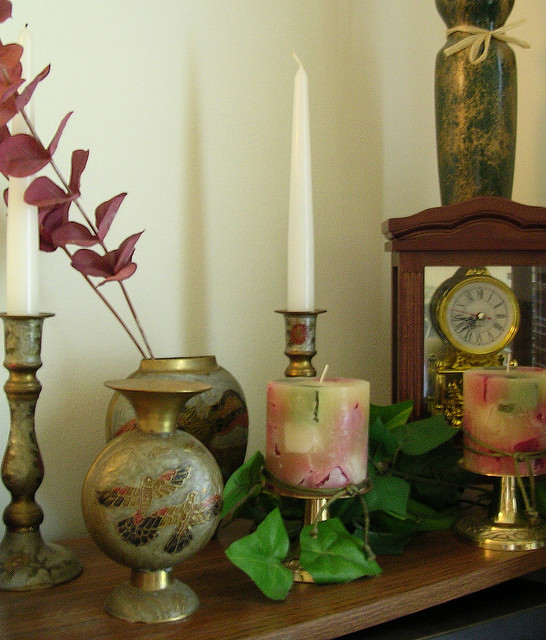<image>What figure is holding the clock? It is not clear what figure is holding the clock. It could be a man or there might not be a figure. What figure is holding the clock? I am not sure what figure is holding the clock. It can be seen that it is either a man or a wooden figure. 